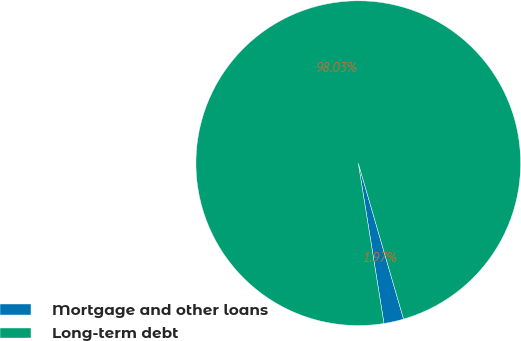<chart> <loc_0><loc_0><loc_500><loc_500><pie_chart><fcel>Mortgage and other loans<fcel>Long-term debt<nl><fcel>1.97%<fcel>98.03%<nl></chart> 